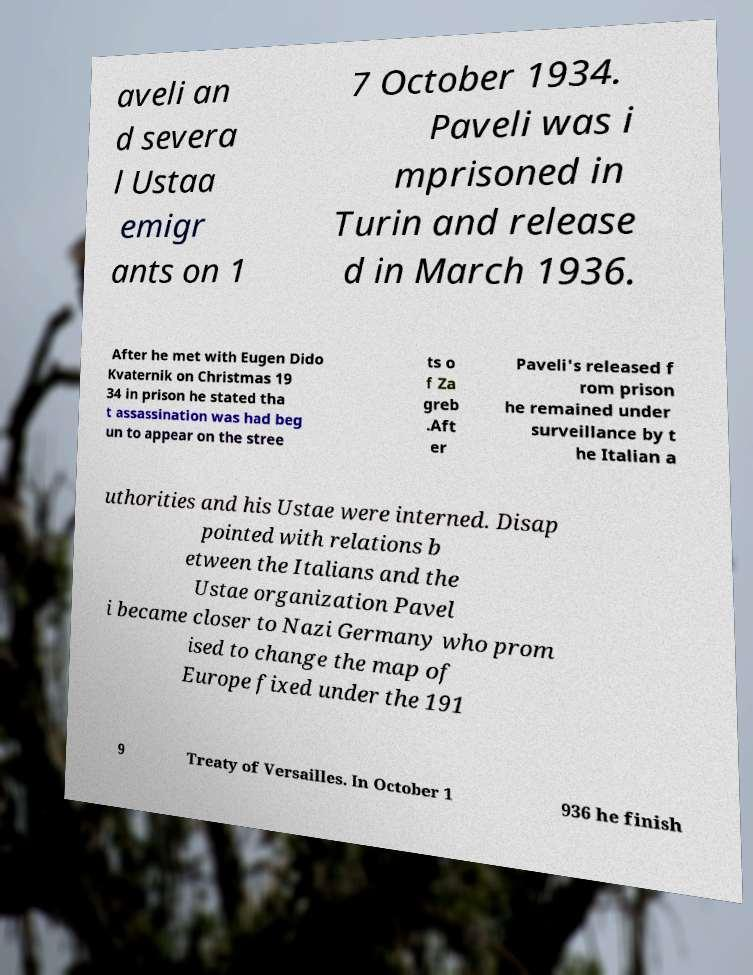For documentation purposes, I need the text within this image transcribed. Could you provide that? aveli an d severa l Ustaa emigr ants on 1 7 October 1934. Paveli was i mprisoned in Turin and release d in March 1936. After he met with Eugen Dido Kvaternik on Christmas 19 34 in prison he stated tha t assassination was had beg un to appear on the stree ts o f Za greb .Aft er Paveli's released f rom prison he remained under surveillance by t he Italian a uthorities and his Ustae were interned. Disap pointed with relations b etween the Italians and the Ustae organization Pavel i became closer to Nazi Germany who prom ised to change the map of Europe fixed under the 191 9 Treaty of Versailles. In October 1 936 he finish 